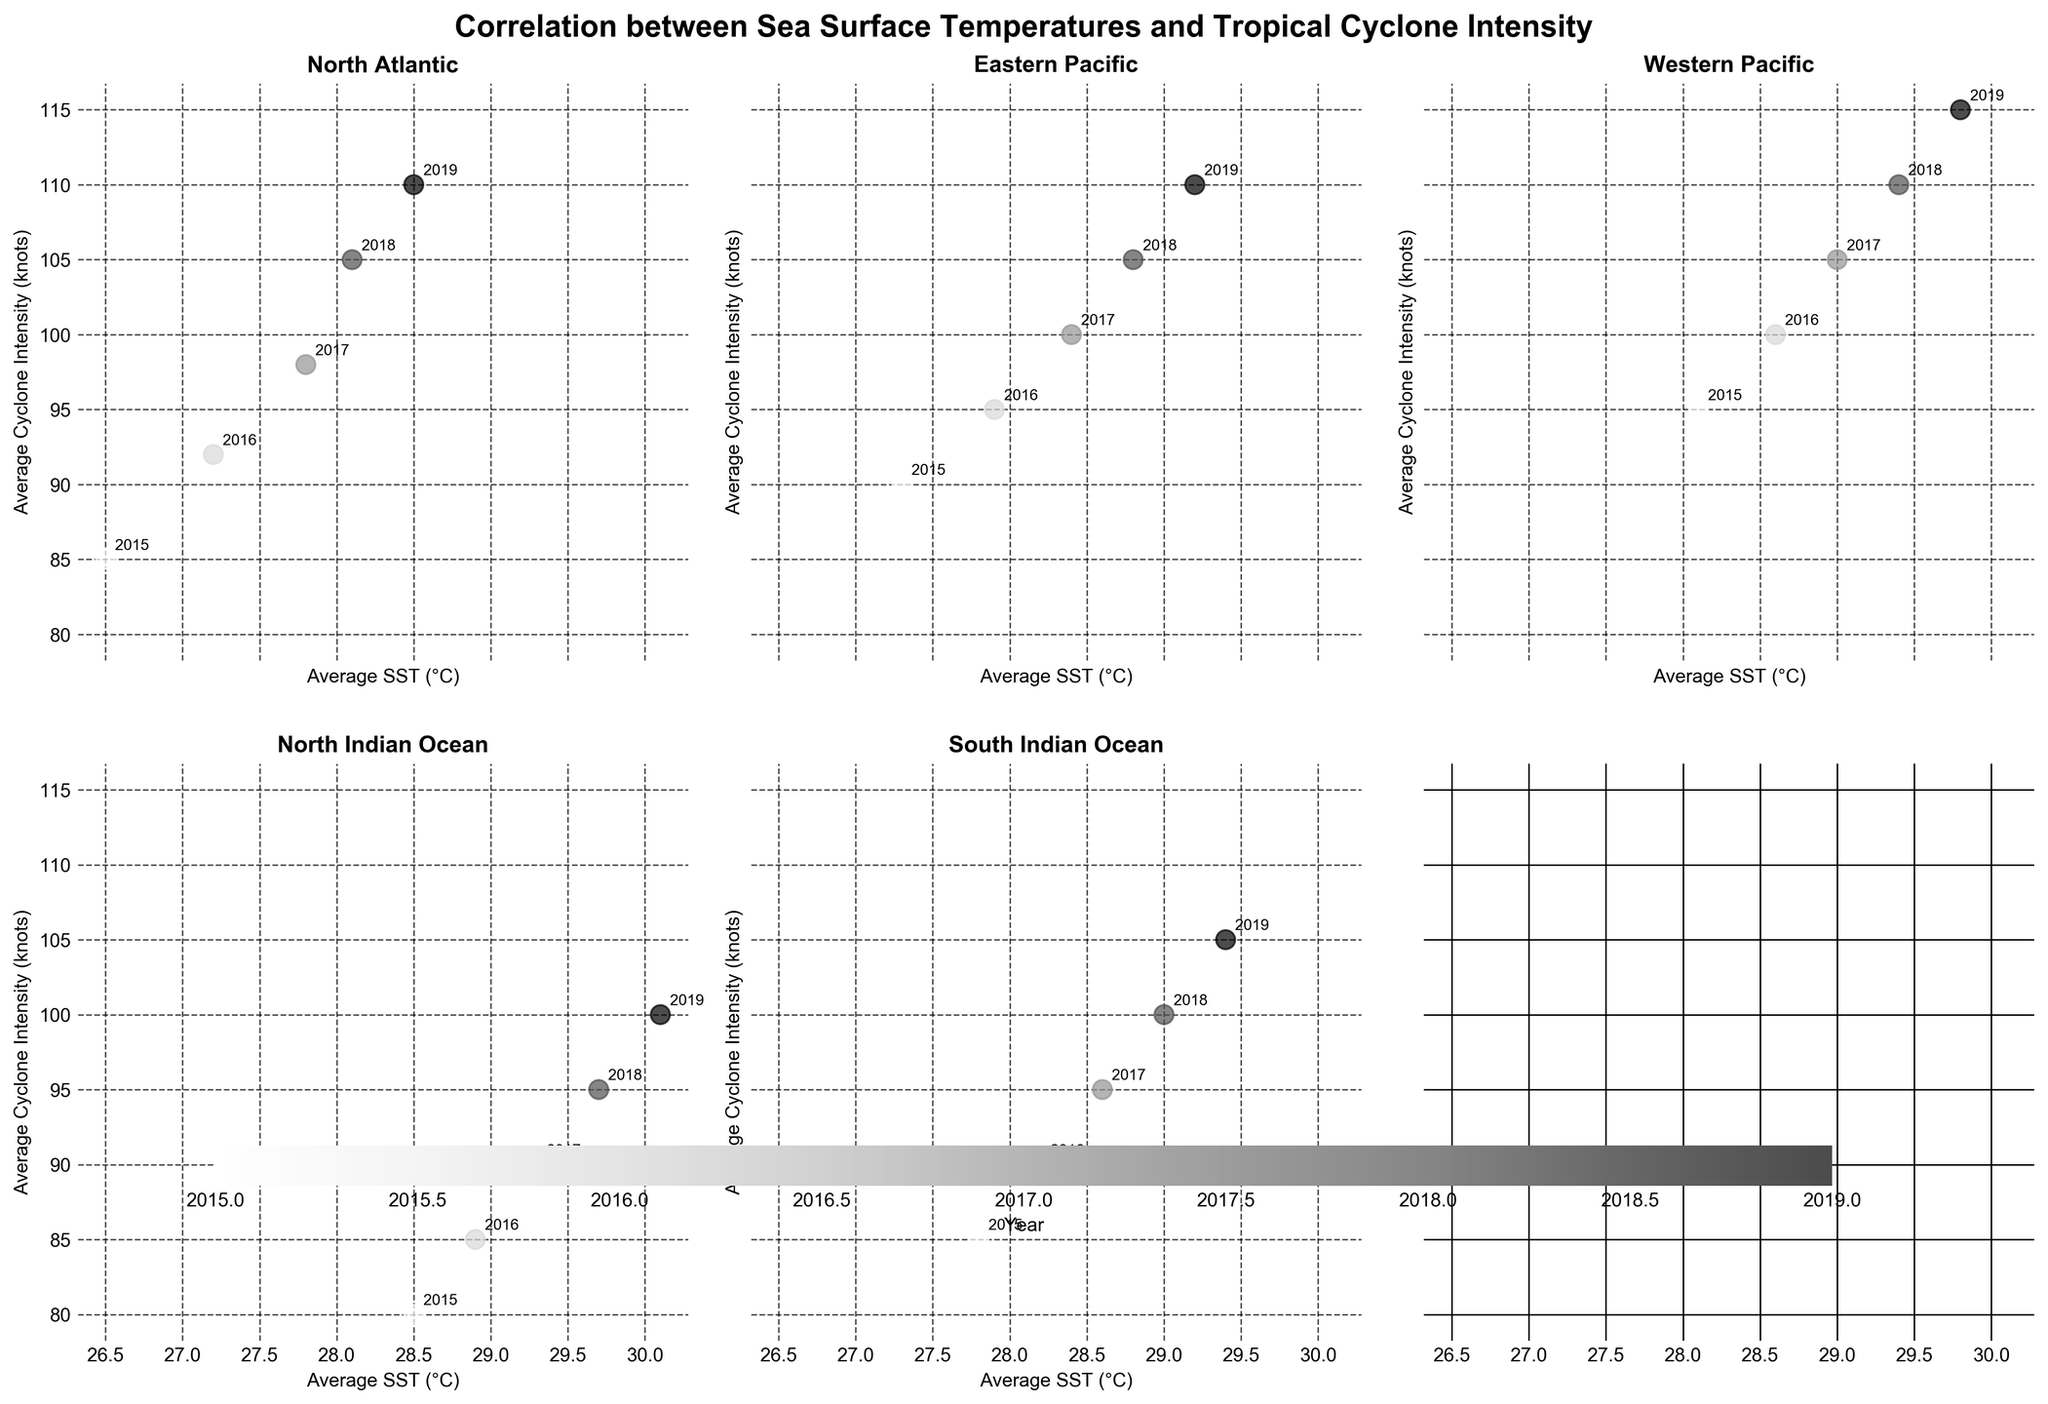What’s the title of the entire figure? The title is at the top of the entire figure and provides a concise overview of what the visual represents.
Answer: Correlation between Sea Surface Temperatures and Tropical Cyclone Intensity How many data points are plotted for the North Atlantic region? By looking at the subplot titled "North Atlantic", you can count the number of points scattered within this region.
Answer: 5 Which region shows the highest average cyclone intensity in 2019? Locate the year 2019 in each subplot and compare the cyclone intensity values. The highest point will indicate the region with the highest average cyclone intensity for that year.
Answer: Western Pacific What is the range of average SST values for the South Indian Ocean region? Find the subplot labeled "South Indian Ocean" and determine the minimum and maximum values of the Average SST (°C) axis.
Answer: 27.8°C to 29.4°C On average, how much did the cyclone intensity increase per year in the North Indian Ocean? Calculate the difference in cyclone intensity between each consecutive year, sum these differences, and then divide by the number of years minus one. ( (85-80)+(90-85)+(95-90)+(100-95) ) / 4
Answer: 5 knots per year Which region shows the steepest increase in cyclone intensity with increasing average SST? Compare the slopes of the scatter plots in each region to see which one has the steepest positive slope.
Answer: Western Pacific In which region and year did the highest SST occur, and what was the corresponding cyclone intensity? Look across all subplots to identify the highest SST value and note the region, year, and corresponding cyclone intensity at that point.
Answer: North Indian Ocean, 2019, 100 knots Which region has the smallest axis range for average cyclone intensity? Identify the region with the smallest difference between the maximum and minimum average cyclone intensities on the y-axis.
Answer: North Indian Ocean Does every region show a positive correlation between SST and cyclone intensity? Observe the trend of the data points in each subplot to see if they generally increase together, indicating a positive correlation.
Answer: Yes 